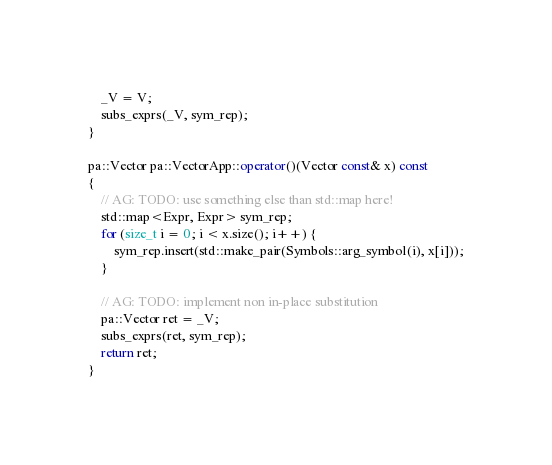Convert code to text. <code><loc_0><loc_0><loc_500><loc_500><_C++_>	_V = V;
	subs_exprs(_V, sym_rep);
}

pa::Vector pa::VectorApp::operator()(Vector const& x) const
{
	// AG: TODO: use something else than std::map here!
	std::map<Expr, Expr> sym_rep;
	for (size_t i = 0; i < x.size(); i++) {
		sym_rep.insert(std::make_pair(Symbols::arg_symbol(i), x[i]));
	}

	// AG: TODO: implement non in-place substitution
	pa::Vector ret = _V;
	subs_exprs(ret, sym_rep);
	return ret;
}
</code> 